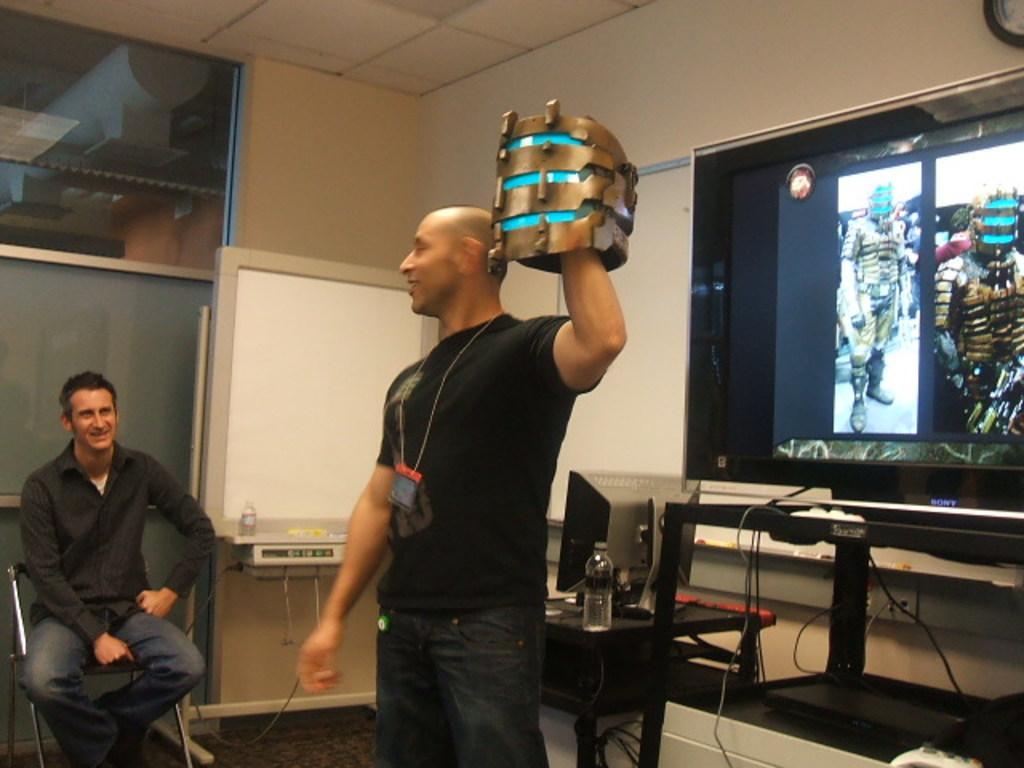How would you summarize this image in a sentence or two? In the center of the image we can see a man standing and holding an object. On the left there is a man sitting on the chair. On the right we can see a screen. In the center there is a computer and a bottle placed on the table. In the background there is a wall. 